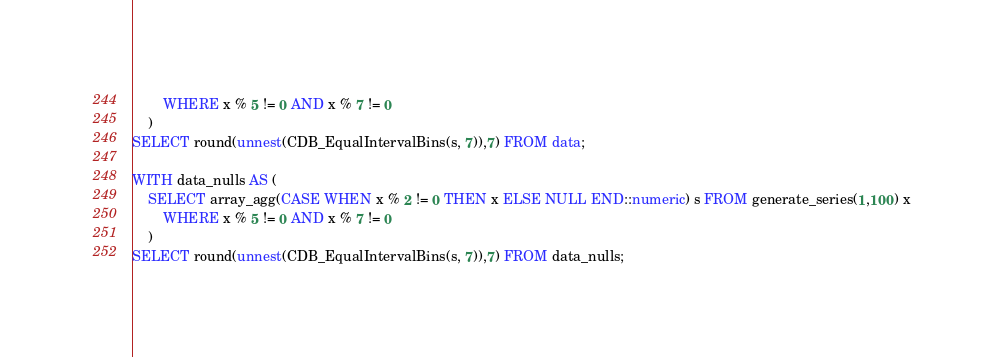Convert code to text. <code><loc_0><loc_0><loc_500><loc_500><_SQL_>        WHERE x % 5 != 0 AND x % 7 != 0
    ) 
SELECT round(unnest(CDB_EqualIntervalBins(s, 7)),7) FROM data;

WITH data_nulls AS (
    SELECT array_agg(CASE WHEN x % 2 != 0 THEN x ELSE NULL END::numeric) s FROM generate_series(1,100) x
        WHERE x % 5 != 0 AND x % 7 != 0
    )
SELECT round(unnest(CDB_EqualIntervalBins(s, 7)),7) FROM data_nulls;
</code> 